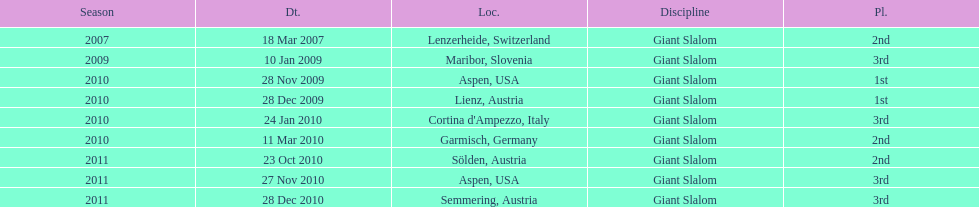What is the only location in the us? Aspen. 